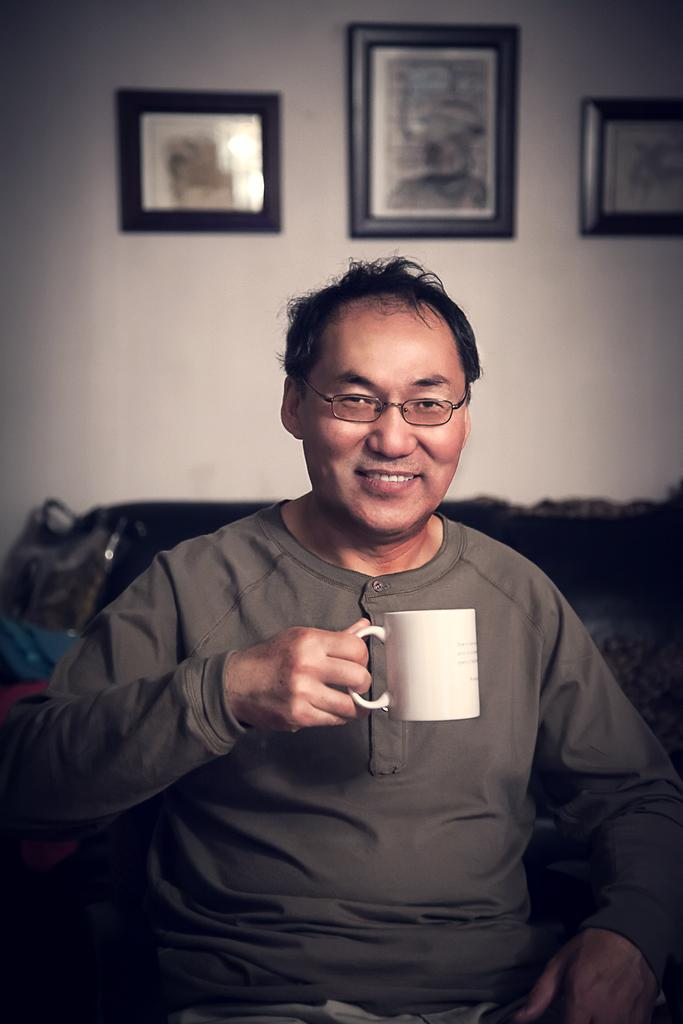Who is present in the image? There is a man in the image. What is the man holding in the image? The man is holding a cup. What is the man's facial expression in the image? The man is smiling. What type of clothing is the man wearing in the image? The man is wearing a T-shirt. What can be seen in the background of the image? There is a wall, a sofa, and photo frames in the background of the image. Can you see a stream in the background of the image? No, there is no stream visible in the background of the image. 